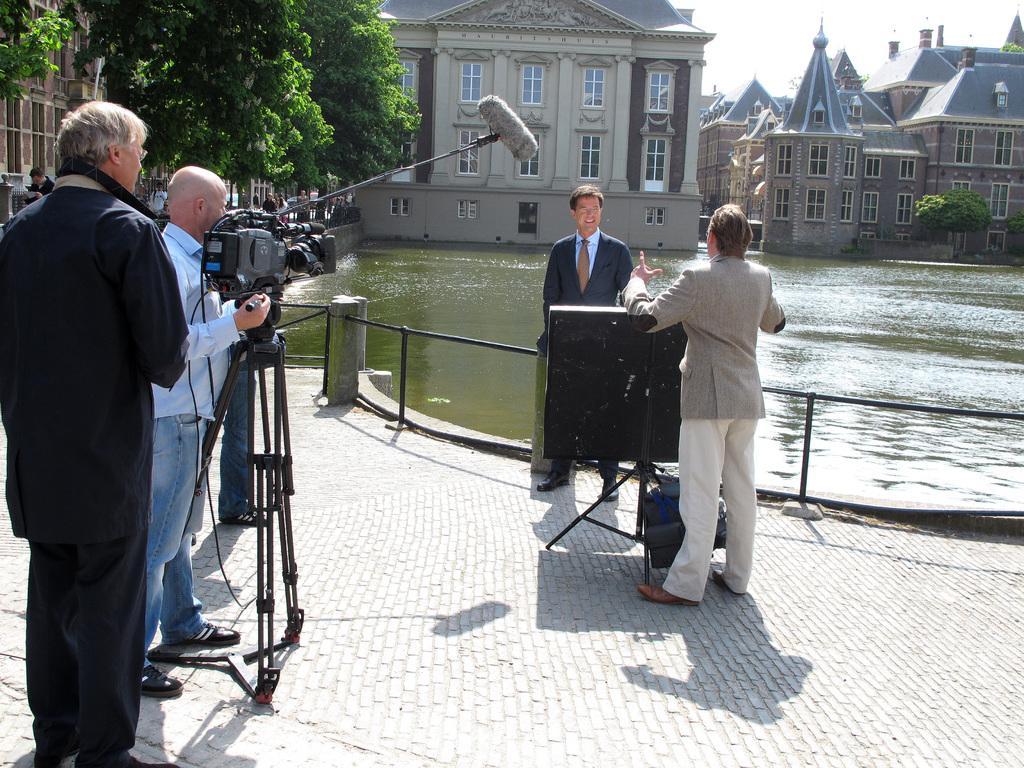Describe this image in one or two sentences. In this image, we can see few people and some objects. At the bottom, we can see the walkway. On the left side of the image, we can see a person is holding a camera. Background we can see water, rod railings, trees, people, buildings, walls, plants, glass windows and sky. 